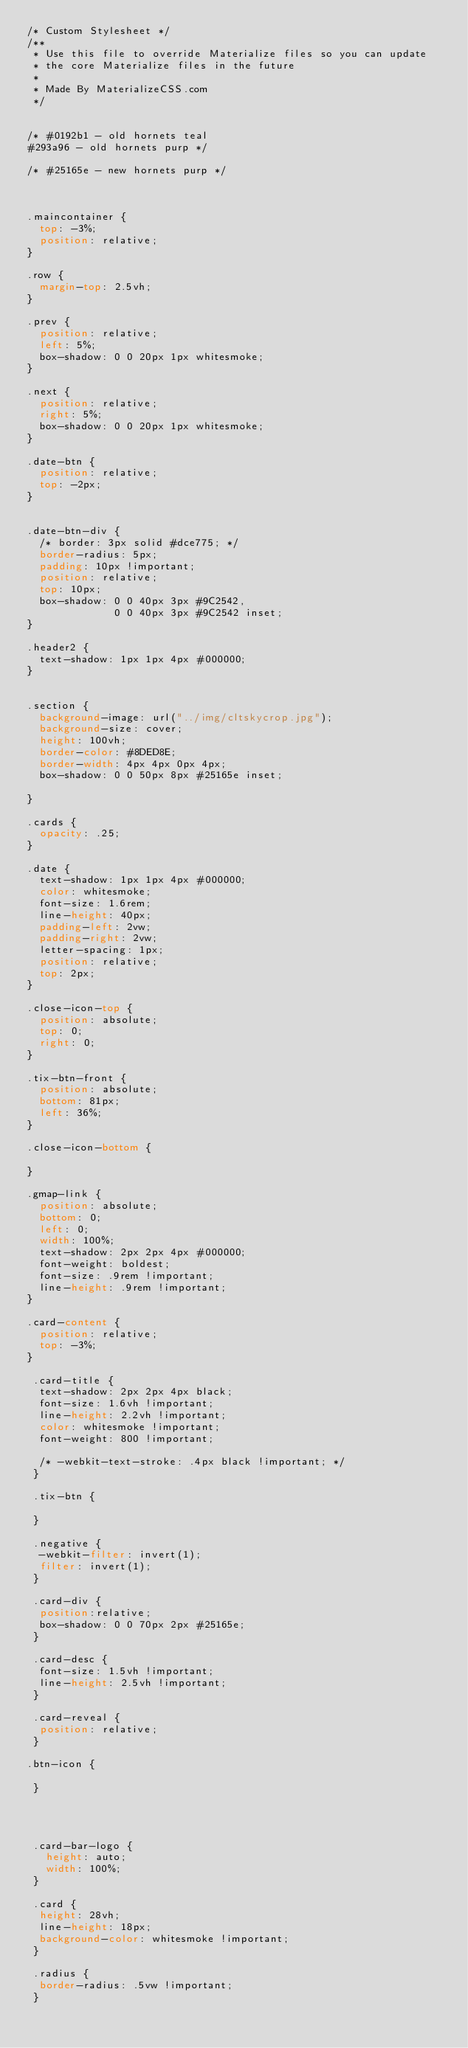<code> <loc_0><loc_0><loc_500><loc_500><_CSS_>/* Custom Stylesheet */
/**
 * Use this file to override Materialize files so you can update
 * the core Materialize files in the future
 *
 * Made By MaterializeCSS.com
 */


/* #0192b1 - old hornets teal
#293a96 - old hornets purp */

/* #25165e - new hornets purp */



.maincontainer {
  top: -3%;
  position: relative;
}

.row {
  margin-top: 2.5vh;
}

.prev {
  position: relative;
  left: 5%;
  box-shadow: 0 0 20px 1px whitesmoke;
}

.next {
  position: relative;
  right: 5%;
  box-shadow: 0 0 20px 1px whitesmoke;
}

.date-btn {
  position: relative;
  top: -2px;
}


.date-btn-div {
  /* border: 3px solid #dce775; */
  border-radius: 5px;
  padding: 10px !important;
  position: relative;
  top: 10px;
  box-shadow: 0 0 40px 3px #9C2542,
              0 0 40px 3px #9C2542 inset;
}

.header2 {
  text-shadow: 1px 1px 4px #000000;
}


.section {
  background-image: url("../img/cltskycrop.jpg");
  background-size: cover;
  height: 100vh;
  border-color: #8DED8E;
  border-width: 4px 4px 0px 4px;
  box-shadow: 0 0 50px 8px #25165e inset;
  
}

.cards {
  opacity: .25;
}

.date {
  text-shadow: 1px 1px 4px #000000;
  color: whitesmoke;
  font-size: 1.6rem;
  line-height: 40px;
  padding-left: 2vw;
  padding-right: 2vw;
  letter-spacing: 1px;
  position: relative;
  top: 2px;
}

.close-icon-top {
  position: absolute;
  top: 0;
  right: 0;
}

.tix-btn-front {
  position: absolute;
  bottom: 81px;
  left: 36%;
}

.close-icon-bottom {
  
}

.gmap-link {
  position: absolute;
  bottom: 0;
  left: 0;
  width: 100%;
  text-shadow: 2px 2px 4px #000000;
  font-weight: boldest;
  font-size: .9rem !important;
  line-height: .9rem !important;
}

.card-content {
  position: relative;
  top: -3%;
}

 .card-title {
  text-shadow: 2px 2px 4px black; 
  font-size: 1.6vh !important;
  line-height: 2.2vh !important;
  color: whitesmoke !important;
  font-weight: 800 !important;
  
  /* -webkit-text-stroke: .4px black !important; */
 }

 .tix-btn {
   
 }

 .negative {
  -webkit-filter: invert(1);
  filter: invert(1);
 }

 .card-div {
  position:relative;
  box-shadow: 0 0 70px 2px #25165e;
 }

 .card-desc {
  font-size: 1.5vh !important;
  line-height: 2.5vh !important;
 }

 .card-reveal {
  position: relative;
 }

.btn-icon {
  
 }




 .card-bar-logo {
   height: auto;
   width: 100%;
 }

 .card {
  height: 28vh;
  line-height: 18px;
  background-color: whitesmoke !important;
 }

 .radius {
  border-radius: .5vw !important;
 }
</code> 